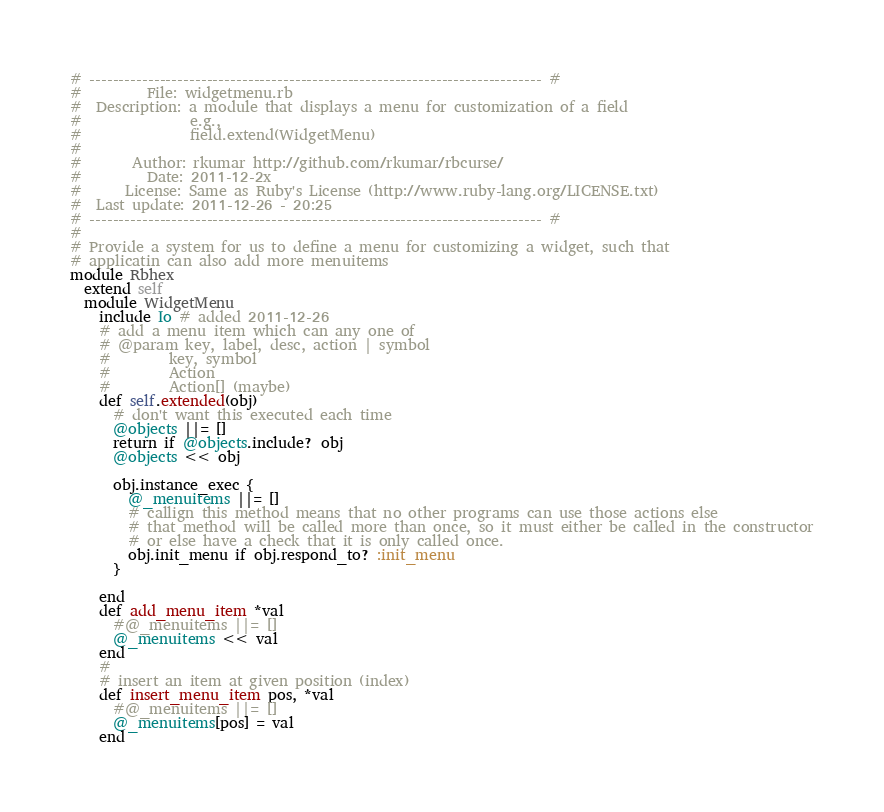<code> <loc_0><loc_0><loc_500><loc_500><_Ruby_># ----------------------------------------------------------------------------- #
#         File: widgetmenu.rb
#  Description: a module that displays a menu for customization of a field
#               e.g.,
#               field.extend(WidgetMenu)
#
#       Author: rkumar http://github.com/rkumar/rbcurse/
#         Date: 2011-12-2x
#      License: Same as Ruby's License (http://www.ruby-lang.org/LICENSE.txt)
#  Last update: 2011-12-26 - 20:25
# ----------------------------------------------------------------------------- #
#
# Provide a system for us to define a menu for customizing a widget, such that
# applicatin can also add more menuitems
module Rbhex
  extend self
  module WidgetMenu
    include Io # added 2011-12-26
    # add a menu item which can any one of
    # @param key, label, desc, action | symbol
    #        key, symbol
    #        Action
    #        Action[] (maybe)
    def self.extended(obj)
      # don't want this executed each time
      @objects ||= []
      return if @objects.include? obj
      @objects << obj

      obj.instance_exec {
        @_menuitems ||= []
        # callign this method means that no other programs can use those actions else
        # that method will be called more than once, so it must either be called in the constructor
        # or else have a check that it is only called once.
        obj.init_menu if obj.respond_to? :init_menu
      }

    end
    def add_menu_item *val
      #@_menuitems ||= []
      @_menuitems << val
    end
    #
    # insert an item at given position (index)
    def insert_menu_item pos, *val
      #@_menuitems ||= []
      @_menuitems[pos] = val
    end</code> 